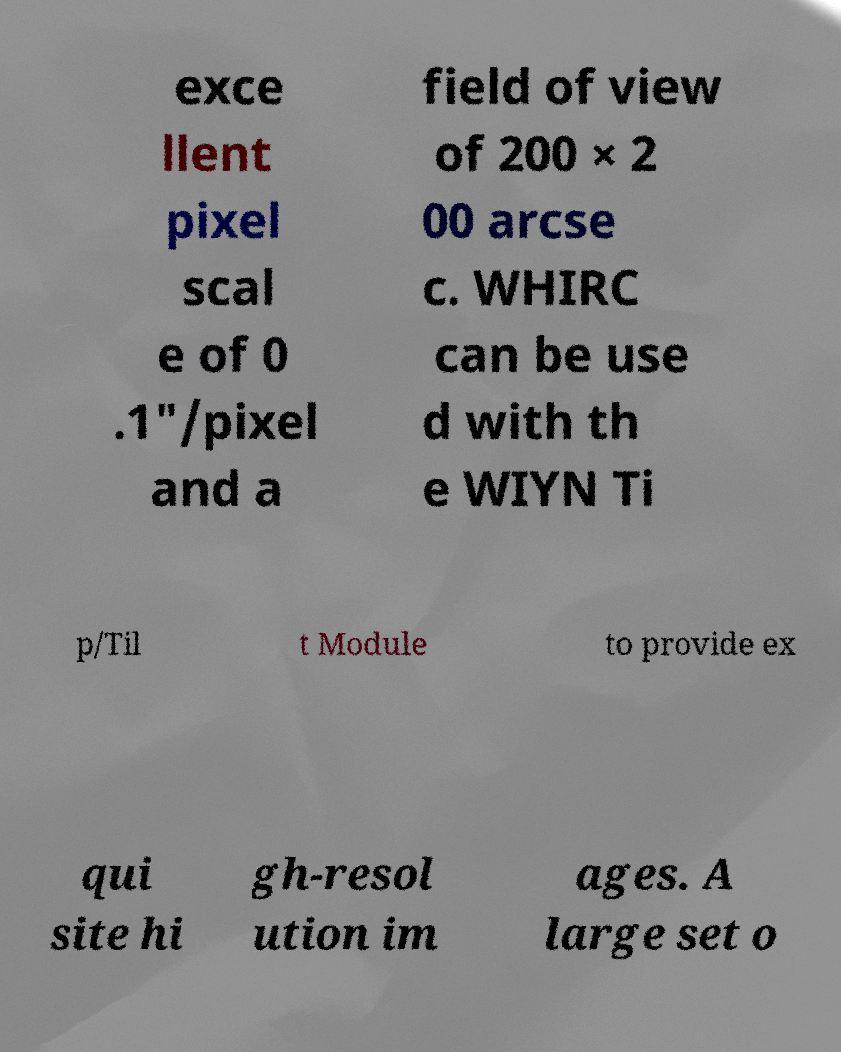Please identify and transcribe the text found in this image. exce llent pixel scal e of 0 .1"/pixel and a field of view of 200 × 2 00 arcse c. WHIRC can be use d with th e WIYN Ti p/Til t Module to provide ex qui site hi gh-resol ution im ages. A large set o 